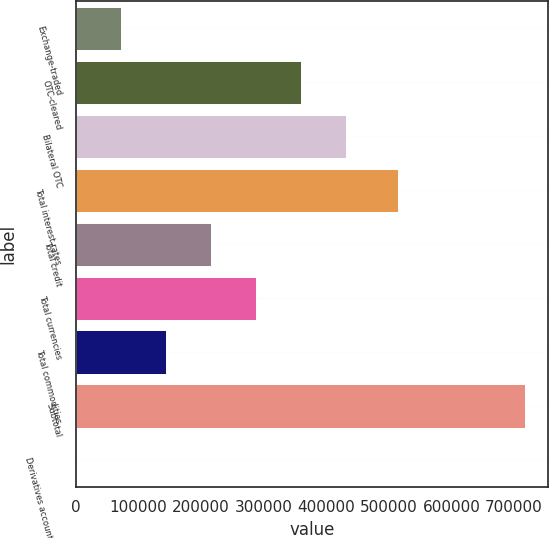Convert chart. <chart><loc_0><loc_0><loc_500><loc_500><bar_chart><fcel>Exchange-traded<fcel>OTC-cleared<fcel>Bilateral OTC<fcel>Total interest rates<fcel>Total credit<fcel>Total currencies<fcel>Total commodities<fcel>Subtotal<fcel>Derivatives accounted for as<nl><fcel>71851.5<fcel>358918<fcel>430684<fcel>514139<fcel>215384<fcel>287151<fcel>143618<fcel>717750<fcel>85<nl></chart> 